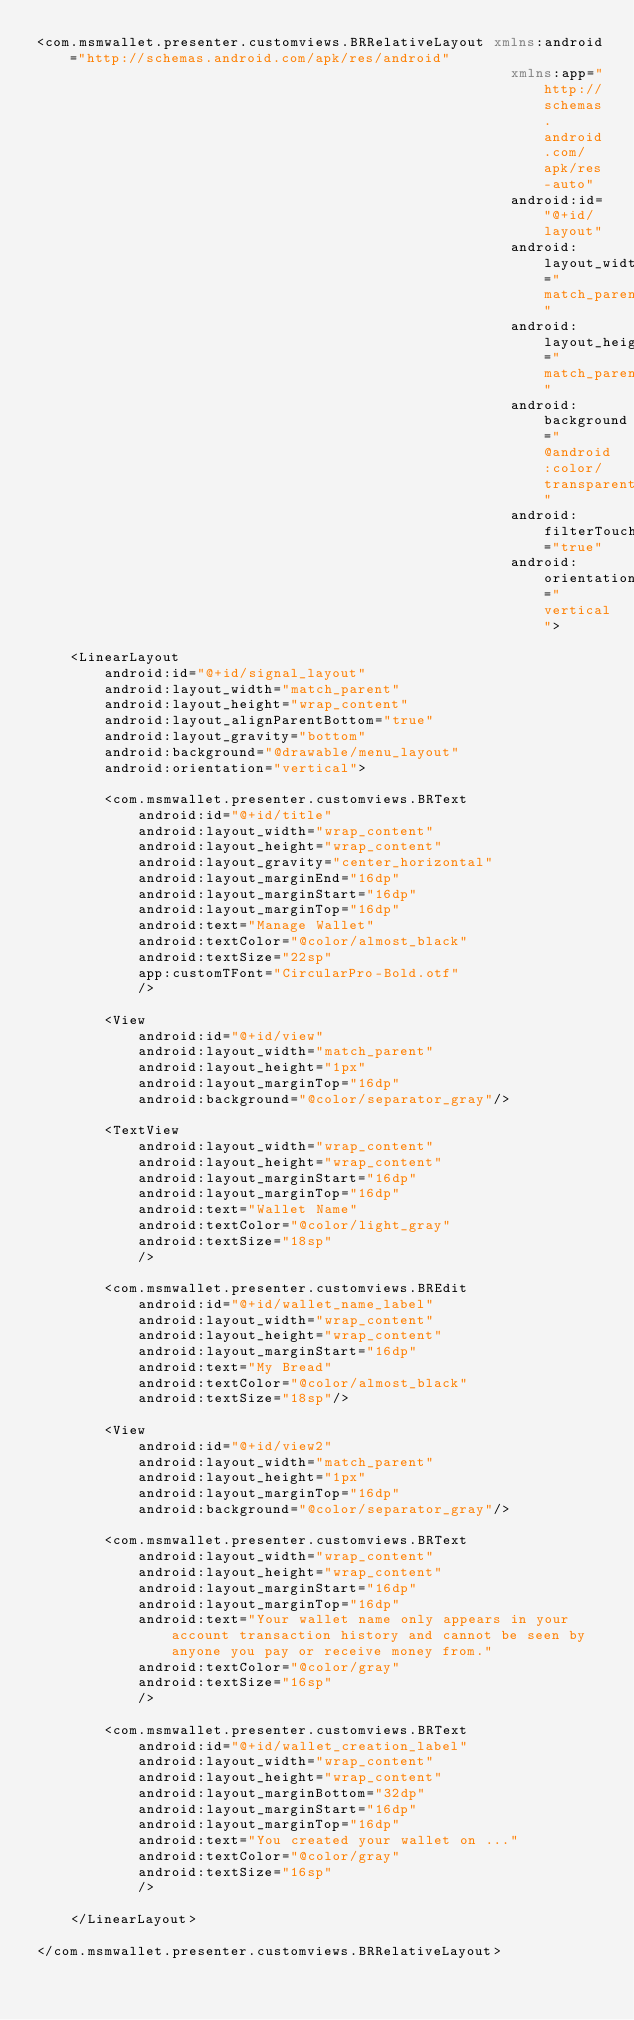<code> <loc_0><loc_0><loc_500><loc_500><_XML_><com.msmwallet.presenter.customviews.BRRelativeLayout xmlns:android="http://schemas.android.com/apk/res/android"
                                                        xmlns:app="http://schemas.android.com/apk/res-auto"
                                                        android:id="@+id/layout"
                                                        android:layout_width="match_parent"
                                                        android:layout_height="match_parent"
                                                        android:background="@android:color/transparent"
                                                        android:filterTouchesWhenObscured="true"
                                                        android:orientation="vertical">

    <LinearLayout
        android:id="@+id/signal_layout"
        android:layout_width="match_parent"
        android:layout_height="wrap_content"
        android:layout_alignParentBottom="true"
        android:layout_gravity="bottom"
        android:background="@drawable/menu_layout"
        android:orientation="vertical">

        <com.msmwallet.presenter.customviews.BRText
            android:id="@+id/title"
            android:layout_width="wrap_content"
            android:layout_height="wrap_content"
            android:layout_gravity="center_horizontal"
            android:layout_marginEnd="16dp"
            android:layout_marginStart="16dp"
            android:layout_marginTop="16dp"
            android:text="Manage Wallet"
            android:textColor="@color/almost_black"
            android:textSize="22sp"
            app:customTFont="CircularPro-Bold.otf"
            />

        <View
            android:id="@+id/view"
            android:layout_width="match_parent"
            android:layout_height="1px"
            android:layout_marginTop="16dp"
            android:background="@color/separator_gray"/>

        <TextView
            android:layout_width="wrap_content"
            android:layout_height="wrap_content"
            android:layout_marginStart="16dp"
            android:layout_marginTop="16dp"
            android:text="Wallet Name"
            android:textColor="@color/light_gray"
            android:textSize="18sp"
            />

        <com.msmwallet.presenter.customviews.BREdit
            android:id="@+id/wallet_name_label"
            android:layout_width="wrap_content"
            android:layout_height="wrap_content"
            android:layout_marginStart="16dp"
            android:text="My Bread"
            android:textColor="@color/almost_black"
            android:textSize="18sp"/>

        <View
            android:id="@+id/view2"
            android:layout_width="match_parent"
            android:layout_height="1px"
            android:layout_marginTop="16dp"
            android:background="@color/separator_gray"/>

        <com.msmwallet.presenter.customviews.BRText
            android:layout_width="wrap_content"
            android:layout_height="wrap_content"
            android:layout_marginStart="16dp"
            android:layout_marginTop="16dp"
            android:text="Your wallet name only appears in your account transaction history and cannot be seen by anyone you pay or receive money from."
            android:textColor="@color/gray"
            android:textSize="16sp"
            />

        <com.msmwallet.presenter.customviews.BRText
            android:id="@+id/wallet_creation_label"
            android:layout_width="wrap_content"
            android:layout_height="wrap_content"
            android:layout_marginBottom="32dp"
            android:layout_marginStart="16dp"
            android:layout_marginTop="16dp"
            android:text="You created your wallet on ..."
            android:textColor="@color/gray"
            android:textSize="16sp"
            />

    </LinearLayout>

</com.msmwallet.presenter.customviews.BRRelativeLayout></code> 